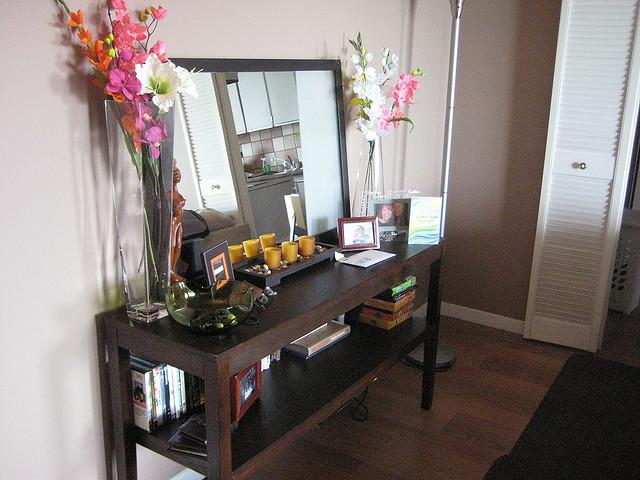What is behind the small table with the flowers? Please explain your reasoning. mirror. The mirror is behind. 